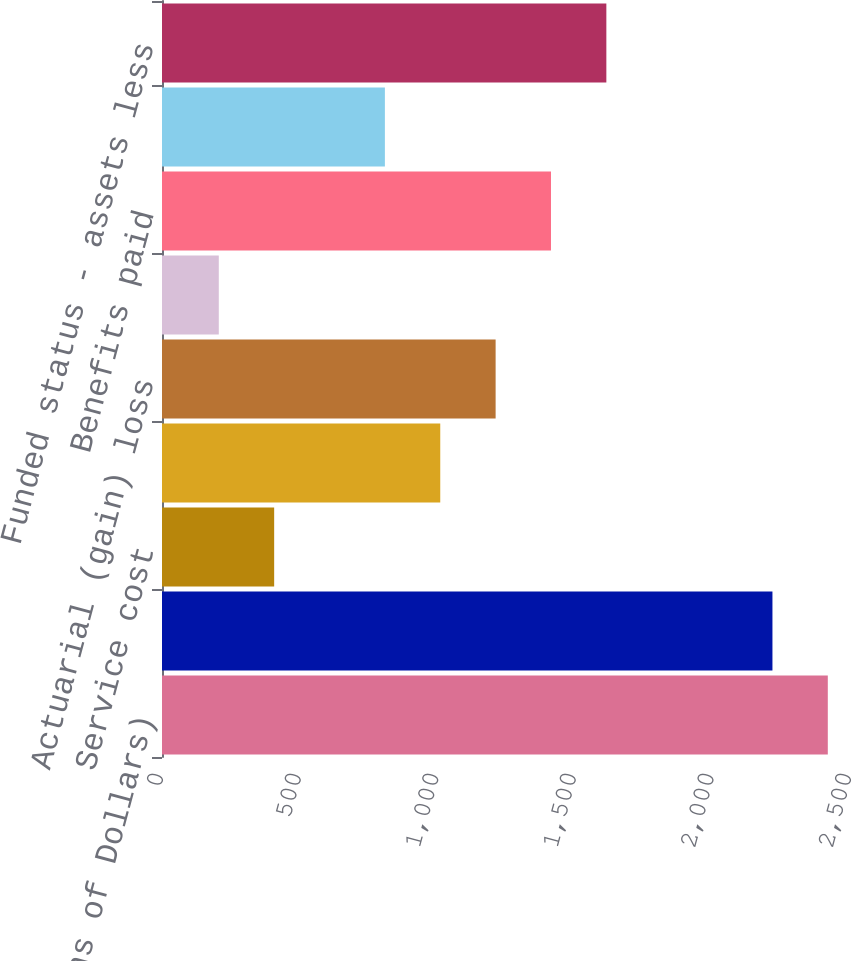Convert chart to OTSL. <chart><loc_0><loc_0><loc_500><loc_500><bar_chart><fcel>(Millions of Dollars)<fcel>Benefit obligation at end of<fcel>Service cost<fcel>Interest cost<fcel>Actuarial (gain) loss<fcel>Acquisitions divestitures and<fcel>Benefits paid<fcel>Employer contributions<fcel>Funded status - assets less<nl><fcel>2419.36<fcel>2218.18<fcel>407.56<fcel>1011.1<fcel>1212.28<fcel>206.38<fcel>1413.46<fcel>809.92<fcel>1614.64<nl></chart> 